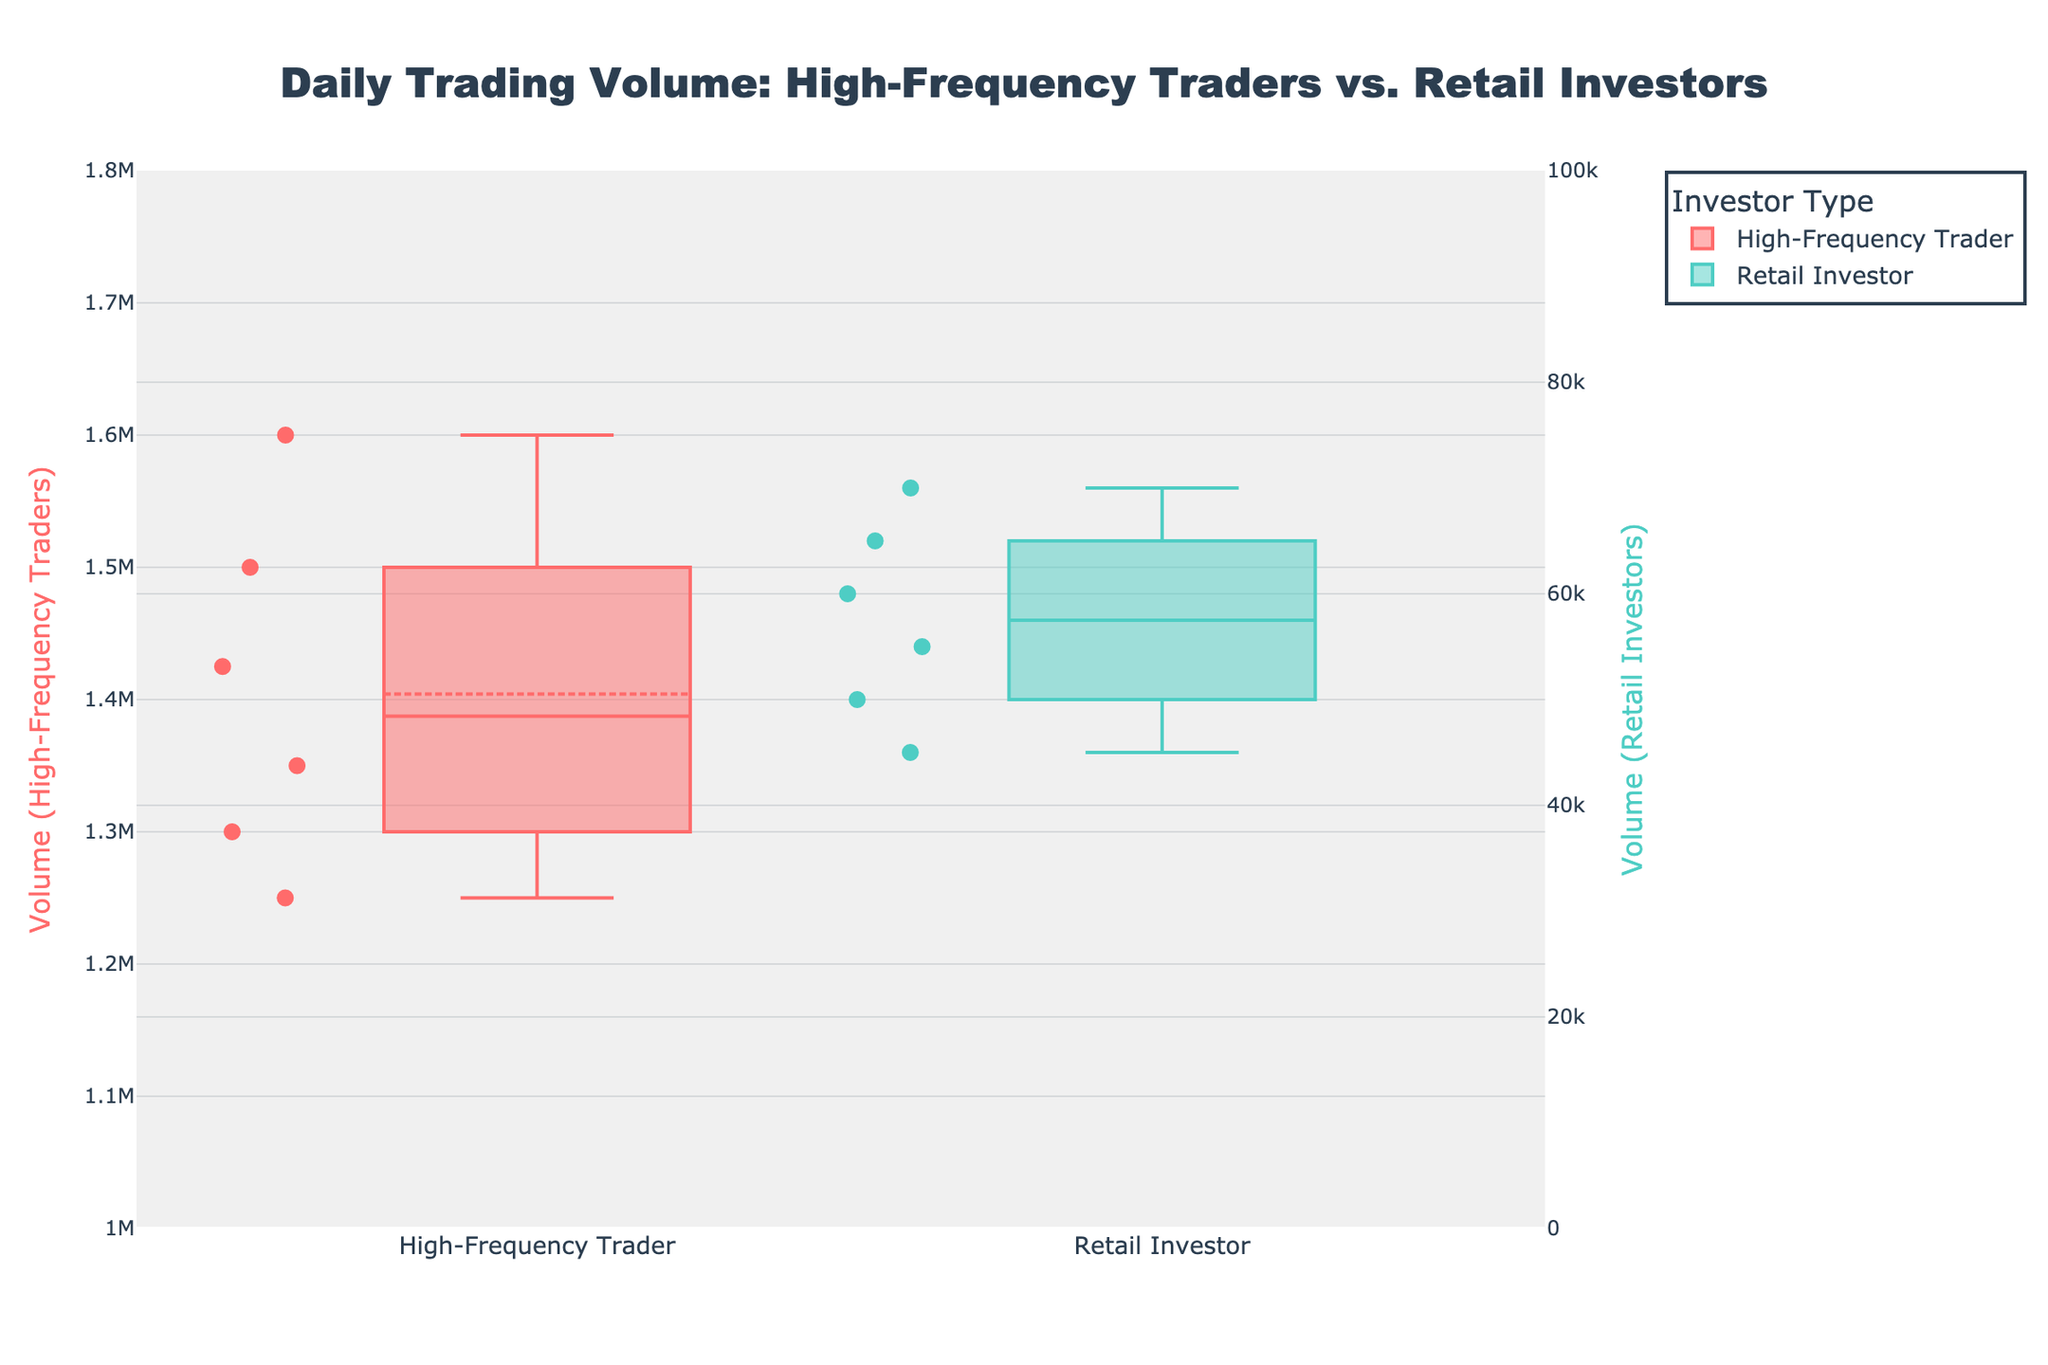What is the title of the plot? The title is located at the top of the plot and clearly states the main focus of the visualization.
Answer: Daily Trading Volume: High-Frequency Traders vs. Retail Investors How many investor types are shown in the plot? There are two distinct groups represented by different colors, each indicating an investor type.
Answer: Two Which investor type has the higher median daily trading volume? The plot shows a horizontal line in each box indicating the median. The median line of the High-Frequency Traders is higher than that of the Retail Investors.
Answer: High-Frequency Traders What is the approximate range of daily trading volumes for High-Frequency Traders? The top and bottom of the box plots indicate the interquartile range (IQR). For High-Frequency Traders, the box ranges from about 1,250,000 to 1,550,000.
Answer: 1,250,000 to 1,550,000 Which investor type has more variability in daily trading volume? Variability is indicated by the length of the box and the whiskers extending from it. The box and whiskers for High-Frequency Traders are longer than those for Retail Investors, indicating more variability.
Answer: High-Frequency Traders What is the approximate median daily trading volume for Retail Investors? The median is represented by the line within the box for Retail Investors, which appears to be around 55,000.
Answer: 55,000 Are there any outliers in the daily trading volumes of High-Frequency Traders? Outliers are typically displayed as individual points outside the whiskers in box plots. There are no points outside the whiskers for High-Frequency Traders, indicating no outliers.
Answer: No What are the primary colors used for each investor type? Each investor type is represented by a distinct color in the box plot: High-Frequency Traders are colored red, and Retail Investors are colored teal.
Answer: Red and Teal How does the daily trading volume of the most active High-Frequency Trader compare to the least active Retail Investor? The highest point within the box and whiskers for High-Frequency Traders is significantly higher than the highest point for Retail Investors. The least active Retail Investor has a volume of 45,000, while the most active High-Frequency Trader is around 1,600,000.
Answer: Much higher What does the secondary y-axis represent? The secondary y-axis is labeled "Volume (Retail Investors)" and is used to better visualize the smaller trading volumes of Retail Investors compared to High-Frequency Traders.
Answer: Volume (Retail Investors) 